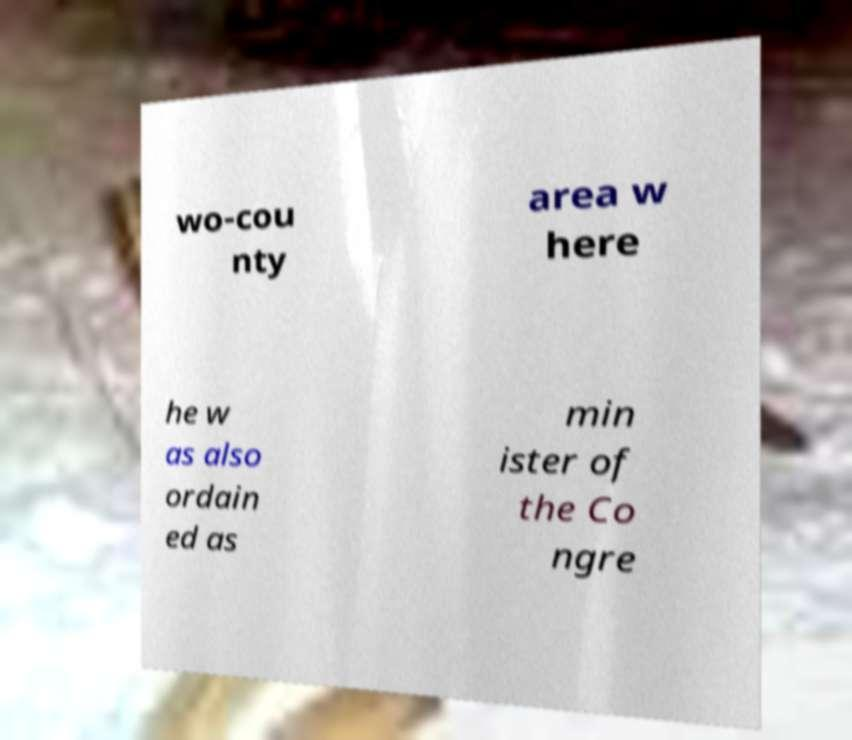Please read and relay the text visible in this image. What does it say? wo-cou nty area w here he w as also ordain ed as min ister of the Co ngre 